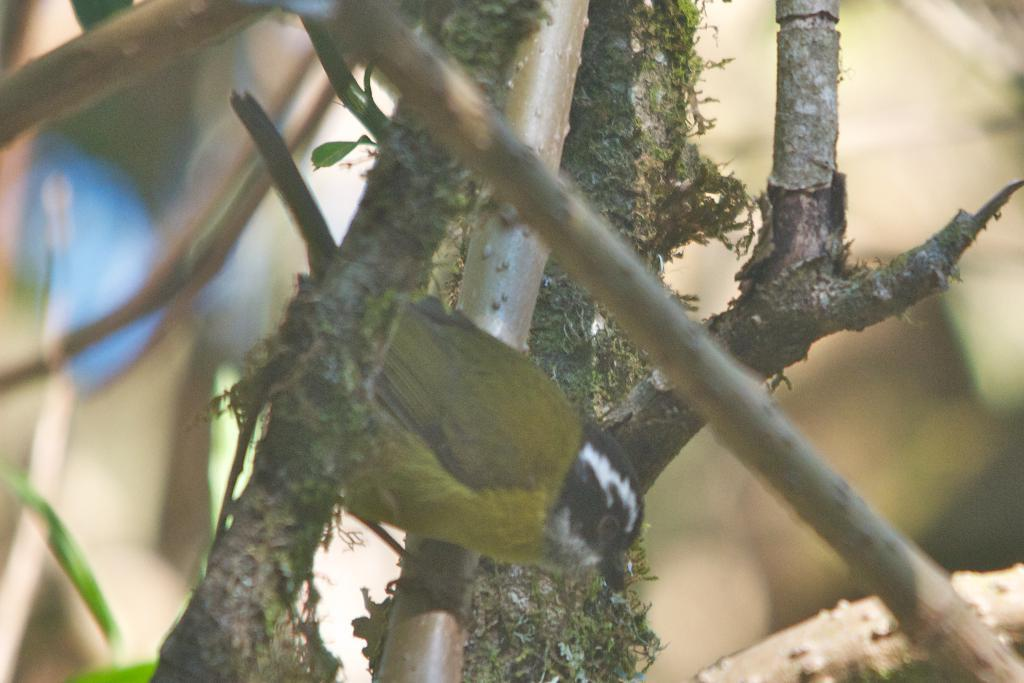What type of animal is in the image? There is a bird in the image. Where is the bird located? The bird is on a branch. Can you describe the background of the image? The background of the image is blurred. What time of day is it in the image, based on the presence of an hour? There is no hour present in the image, so it is not possible to determine the time of day. 